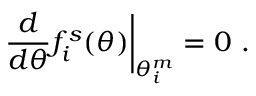<formula> <loc_0><loc_0><loc_500><loc_500>\frac { d } { d \theta } f _ { i } ^ { s } ( \theta ) \right | _ { \theta _ { i } ^ { m } } = 0 \, .</formula> 